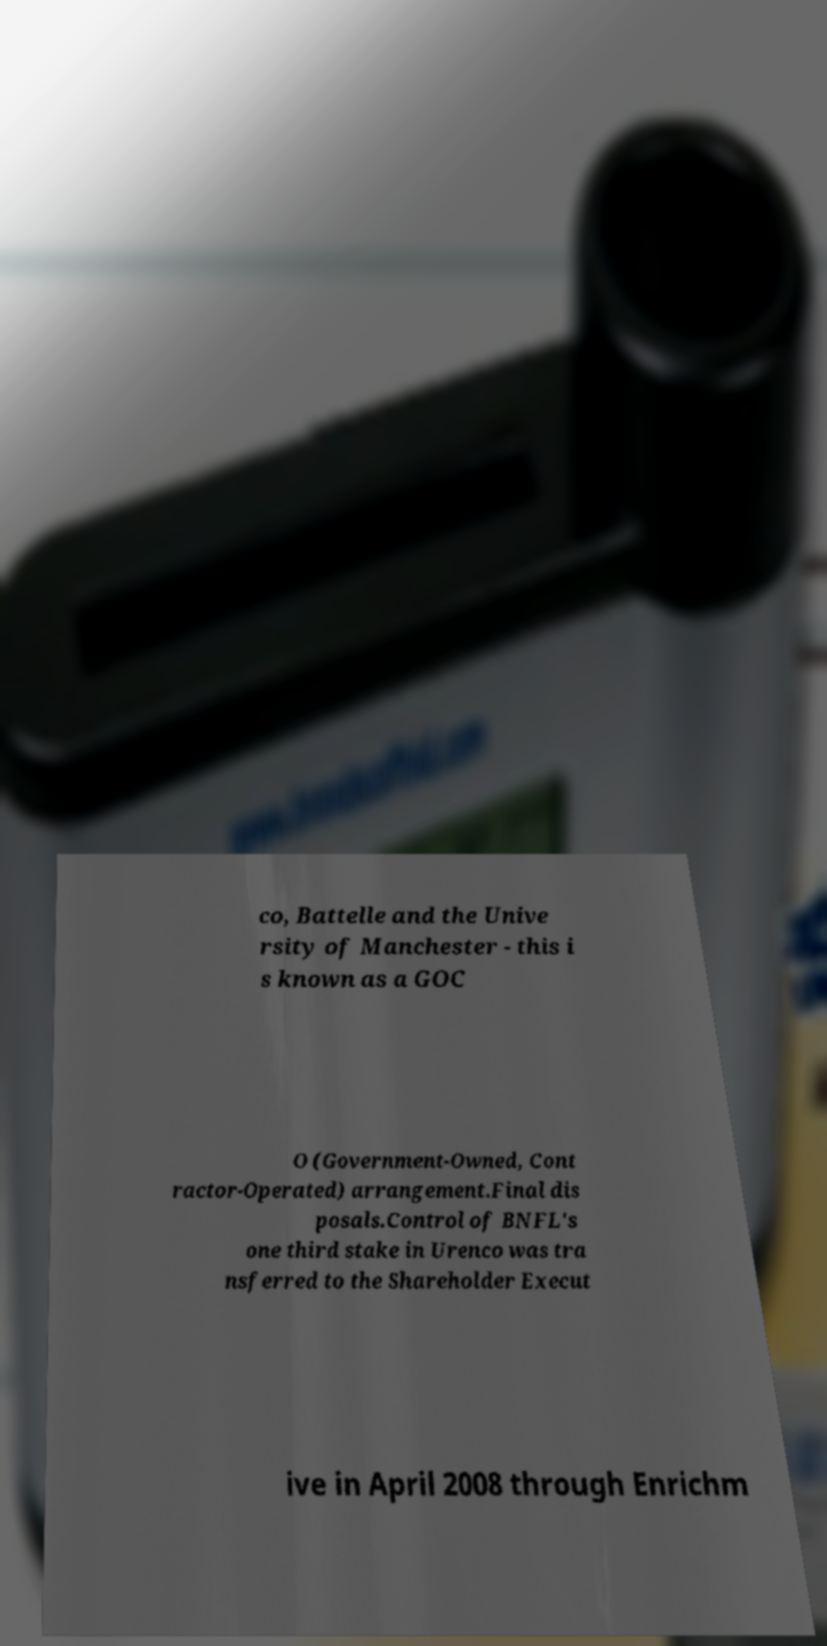Could you assist in decoding the text presented in this image and type it out clearly? co, Battelle and the Unive rsity of Manchester - this i s known as a GOC O (Government-Owned, Cont ractor-Operated) arrangement.Final dis posals.Control of BNFL's one third stake in Urenco was tra nsferred to the Shareholder Execut ive in April 2008 through Enrichm 